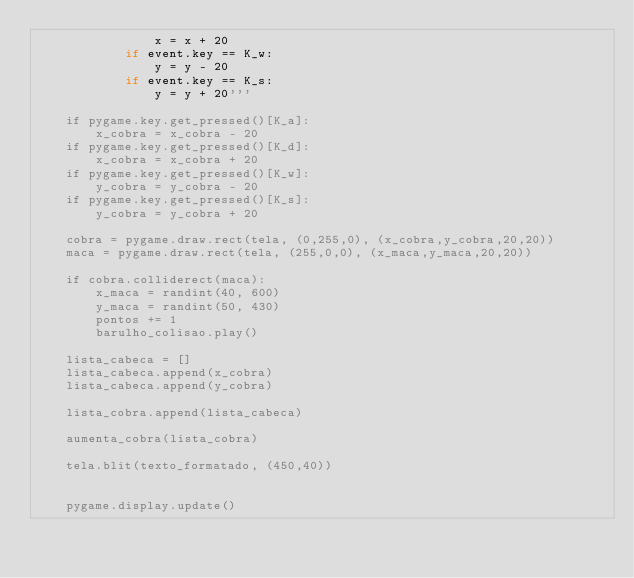Convert code to text. <code><loc_0><loc_0><loc_500><loc_500><_Python_>                x = x + 20
            if event.key == K_w:
                y = y - 20
            if event.key == K_s:
                y = y + 20'''
                        
    if pygame.key.get_pressed()[K_a]:
        x_cobra = x_cobra - 20
    if pygame.key.get_pressed()[K_d]:
        x_cobra = x_cobra + 20 
    if pygame.key.get_pressed()[K_w]:
        y_cobra = y_cobra - 20
    if pygame.key.get_pressed()[K_s]:
        y_cobra = y_cobra + 20
        
    cobra = pygame.draw.rect(tela, (0,255,0), (x_cobra,y_cobra,20,20))
    maca = pygame.draw.rect(tela, (255,0,0), (x_maca,y_maca,20,20))
    
    if cobra.colliderect(maca):
        x_maca = randint(40, 600)
        y_maca = randint(50, 430)
        pontos += 1
        barulho_colisao.play()

    lista_cabeca = []
    lista_cabeca.append(x_cobra)
    lista_cabeca.append(y_cobra)
    
    lista_cobra.append(lista_cabeca)

    aumenta_cobra(lista_cobra)

    tela.blit(texto_formatado, (450,40))

    
    pygame.display.update()
</code> 